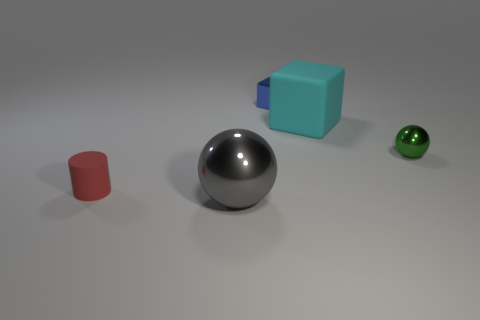Add 5 metal objects. How many objects exist? 10 Subtract 1 balls. How many balls are left? 1 Subtract 1 gray spheres. How many objects are left? 4 Subtract all spheres. How many objects are left? 3 Subtract all purple balls. Subtract all red cubes. How many balls are left? 2 Subtract all big yellow metallic cubes. Subtract all blue blocks. How many objects are left? 4 Add 4 gray metallic objects. How many gray metallic objects are left? 5 Add 3 metallic cubes. How many metallic cubes exist? 4 